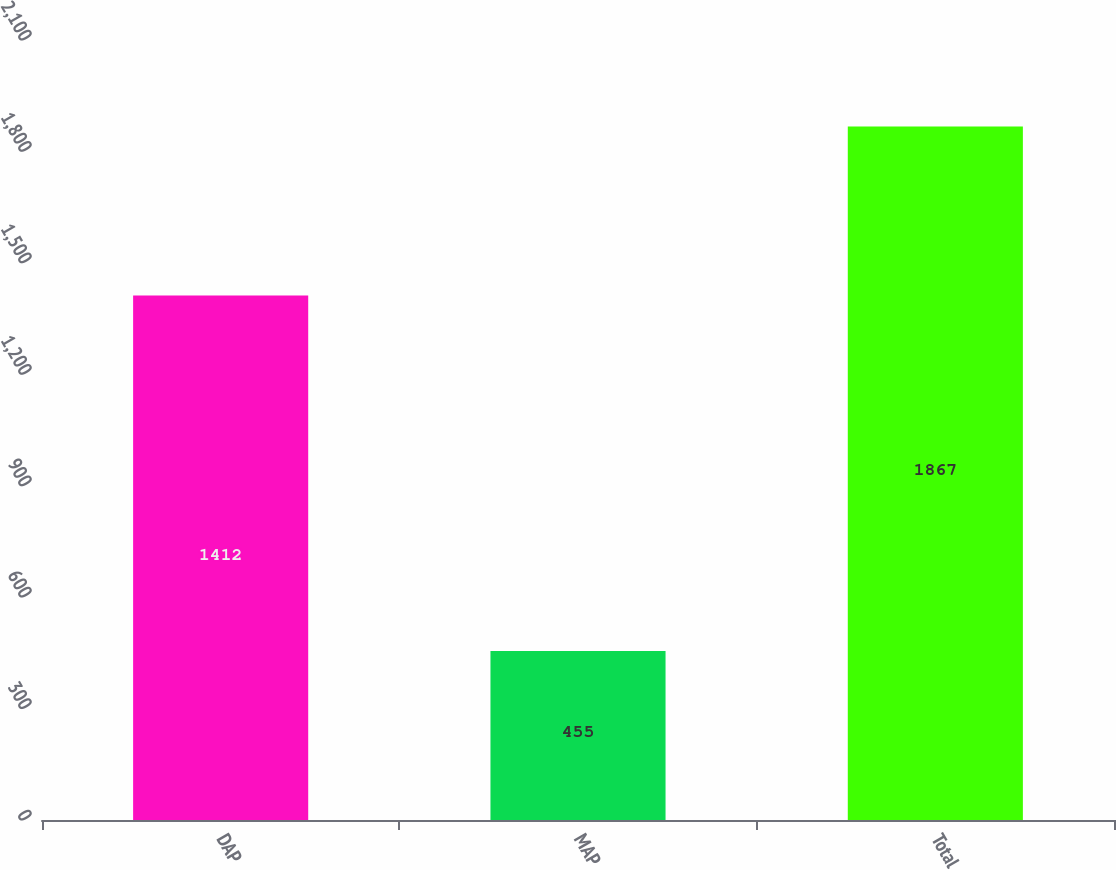Convert chart to OTSL. <chart><loc_0><loc_0><loc_500><loc_500><bar_chart><fcel>DAP<fcel>MAP<fcel>Total<nl><fcel>1412<fcel>455<fcel>1867<nl></chart> 